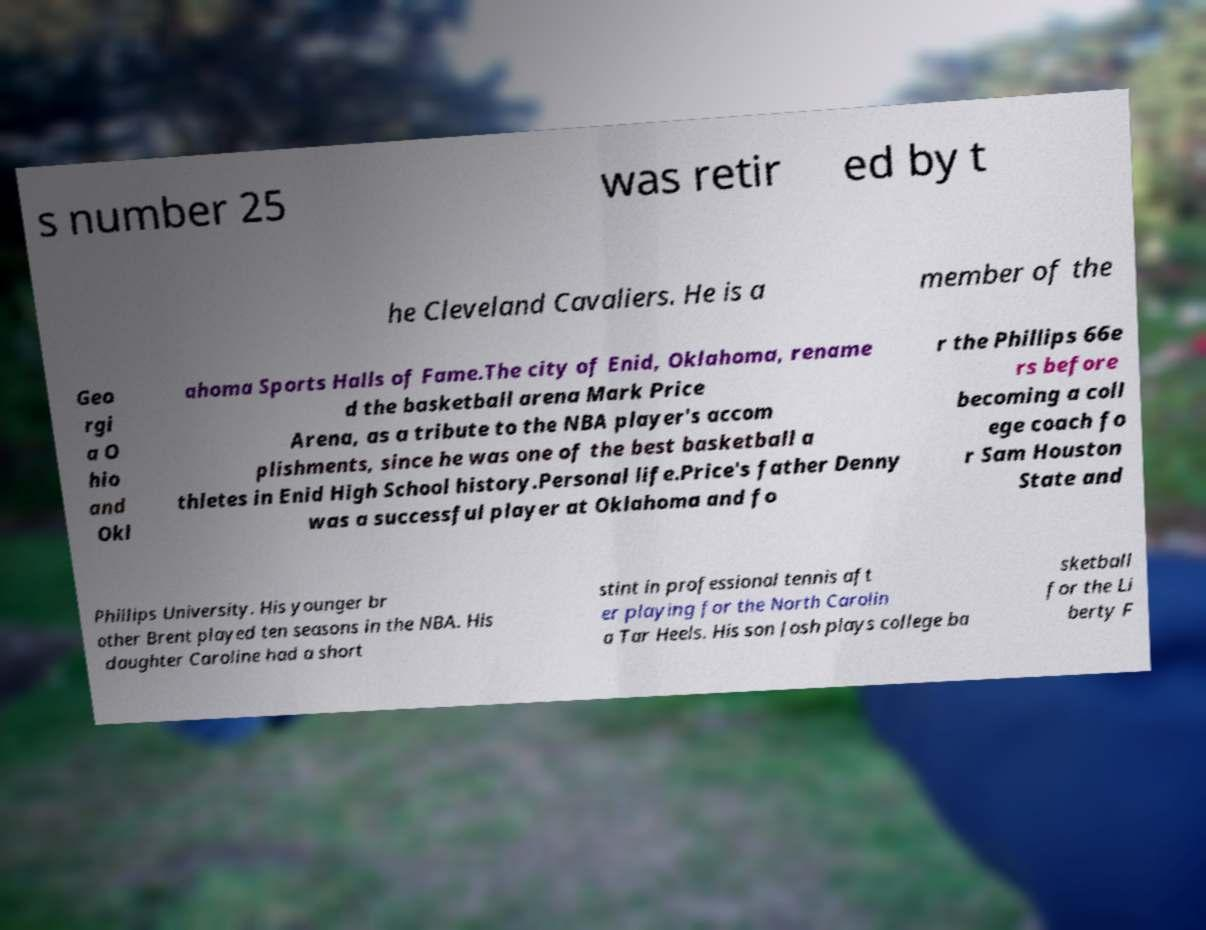For documentation purposes, I need the text within this image transcribed. Could you provide that? s number 25 was retir ed by t he Cleveland Cavaliers. He is a member of the Geo rgi a O hio and Okl ahoma Sports Halls of Fame.The city of Enid, Oklahoma, rename d the basketball arena Mark Price Arena, as a tribute to the NBA player's accom plishments, since he was one of the best basketball a thletes in Enid High School history.Personal life.Price's father Denny was a successful player at Oklahoma and fo r the Phillips 66e rs before becoming a coll ege coach fo r Sam Houston State and Phillips University. His younger br other Brent played ten seasons in the NBA. His daughter Caroline had a short stint in professional tennis aft er playing for the North Carolin a Tar Heels. His son Josh plays college ba sketball for the Li berty F 